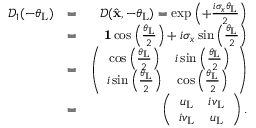Convert formula to latex. <formula><loc_0><loc_0><loc_500><loc_500>\begin{array} { r l r } { \mathcal { D } _ { 1 } ( - \theta _ { L } ) } & { = } & { \mathcal { D } ( \hat { x } , - \theta _ { L } ) = \exp \left ( + \frac { i \sigma _ { x } \theta _ { L } } { 2 } \right ) } \\ & { = } & { { 1 } \cos \left ( \frac { \theta _ { L } } { 2 } \right ) + i \sigma _ { x } \sin \left ( \frac { \theta _ { L } } { 2 } \right ) } \\ & { = } & { \left ( \begin{array} { c c } { \cos \left ( \frac { \theta _ { L } } { 2 } \right ) } & { i \sin \left ( \frac { \theta _ { L } } { 2 } \right ) } \\ { i \sin \left ( \frac { \theta _ { L } } { 2 } \right ) } & { \cos \left ( \frac { \theta _ { L } } { 2 } \right ) } \end{array} \right ) } \\ & { = } & { \left ( \begin{array} { c c } { u _ { L } } & { i v _ { L } } \\ { i v _ { L } } & { u _ { L } } \end{array} \right ) . } \end{array}</formula> 